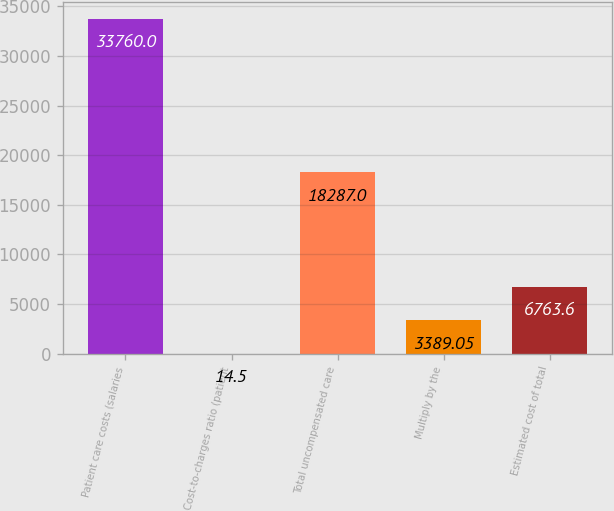Convert chart. <chart><loc_0><loc_0><loc_500><loc_500><bar_chart><fcel>Patient care costs (salaries<fcel>Cost-to-charges ratio (patient<fcel>Total uncompensated care<fcel>Multiply by the<fcel>Estimated cost of total<nl><fcel>33760<fcel>14.5<fcel>18287<fcel>3389.05<fcel>6763.6<nl></chart> 